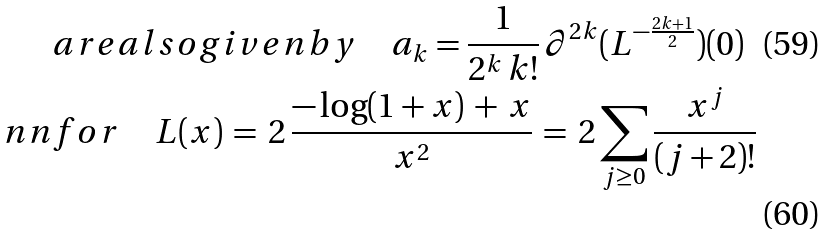Convert formula to latex. <formula><loc_0><loc_0><loc_500><loc_500>& a r e a l s o g i v e n b y \quad a _ { k } = \frac { 1 } { 2 ^ { k } \, k ! } \, \partial ^ { 2 k } ( L ^ { - \frac { 2 k + 1 } { 2 } } ) ( 0 ) \\ \ n n & f o r \quad L ( x ) \, = \, 2 \, \frac { - \log ( 1 + x ) \, + \, x } { x ^ { 2 } } \, = \, 2 \sum _ { j \geq 0 } \frac { x ^ { j } } { ( j + 2 ) ! }</formula> 